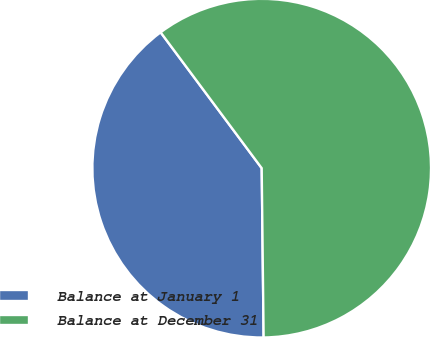<chart> <loc_0><loc_0><loc_500><loc_500><pie_chart><fcel>Balance at January 1<fcel>Balance at December 31<nl><fcel>40.0%<fcel>60.0%<nl></chart> 